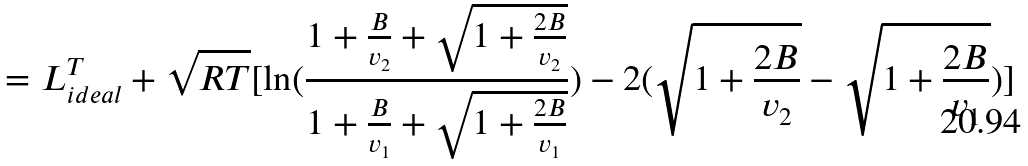Convert formula to latex. <formula><loc_0><loc_0><loc_500><loc_500>= L ^ { T } _ { i d e a l } + \sqrt { R T } [ \ln ( \frac { 1 + \frac { B } { v _ { 2 } } + \sqrt { 1 + \frac { 2 B } { v _ { 2 } } } } { 1 + \frac { B } { v _ { 1 } } + \sqrt { 1 + \frac { 2 B } { v _ { 1 } } } } ) - 2 ( \sqrt { 1 + \frac { 2 B } { v _ { 2 } } } - \sqrt { 1 + \frac { 2 B } { v _ { 1 } } } ) ]</formula> 